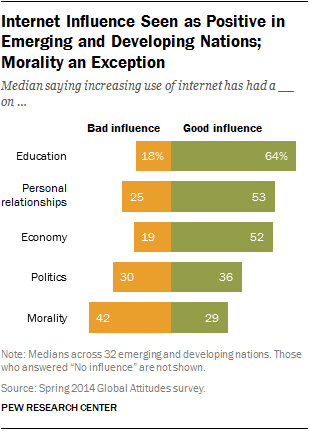Mention a couple of crucial points in this snapshot. The education sector has the greatest difference between positive influence and negative influence compared to other sectors. The yellow bar represents the value of "Bad influence. 